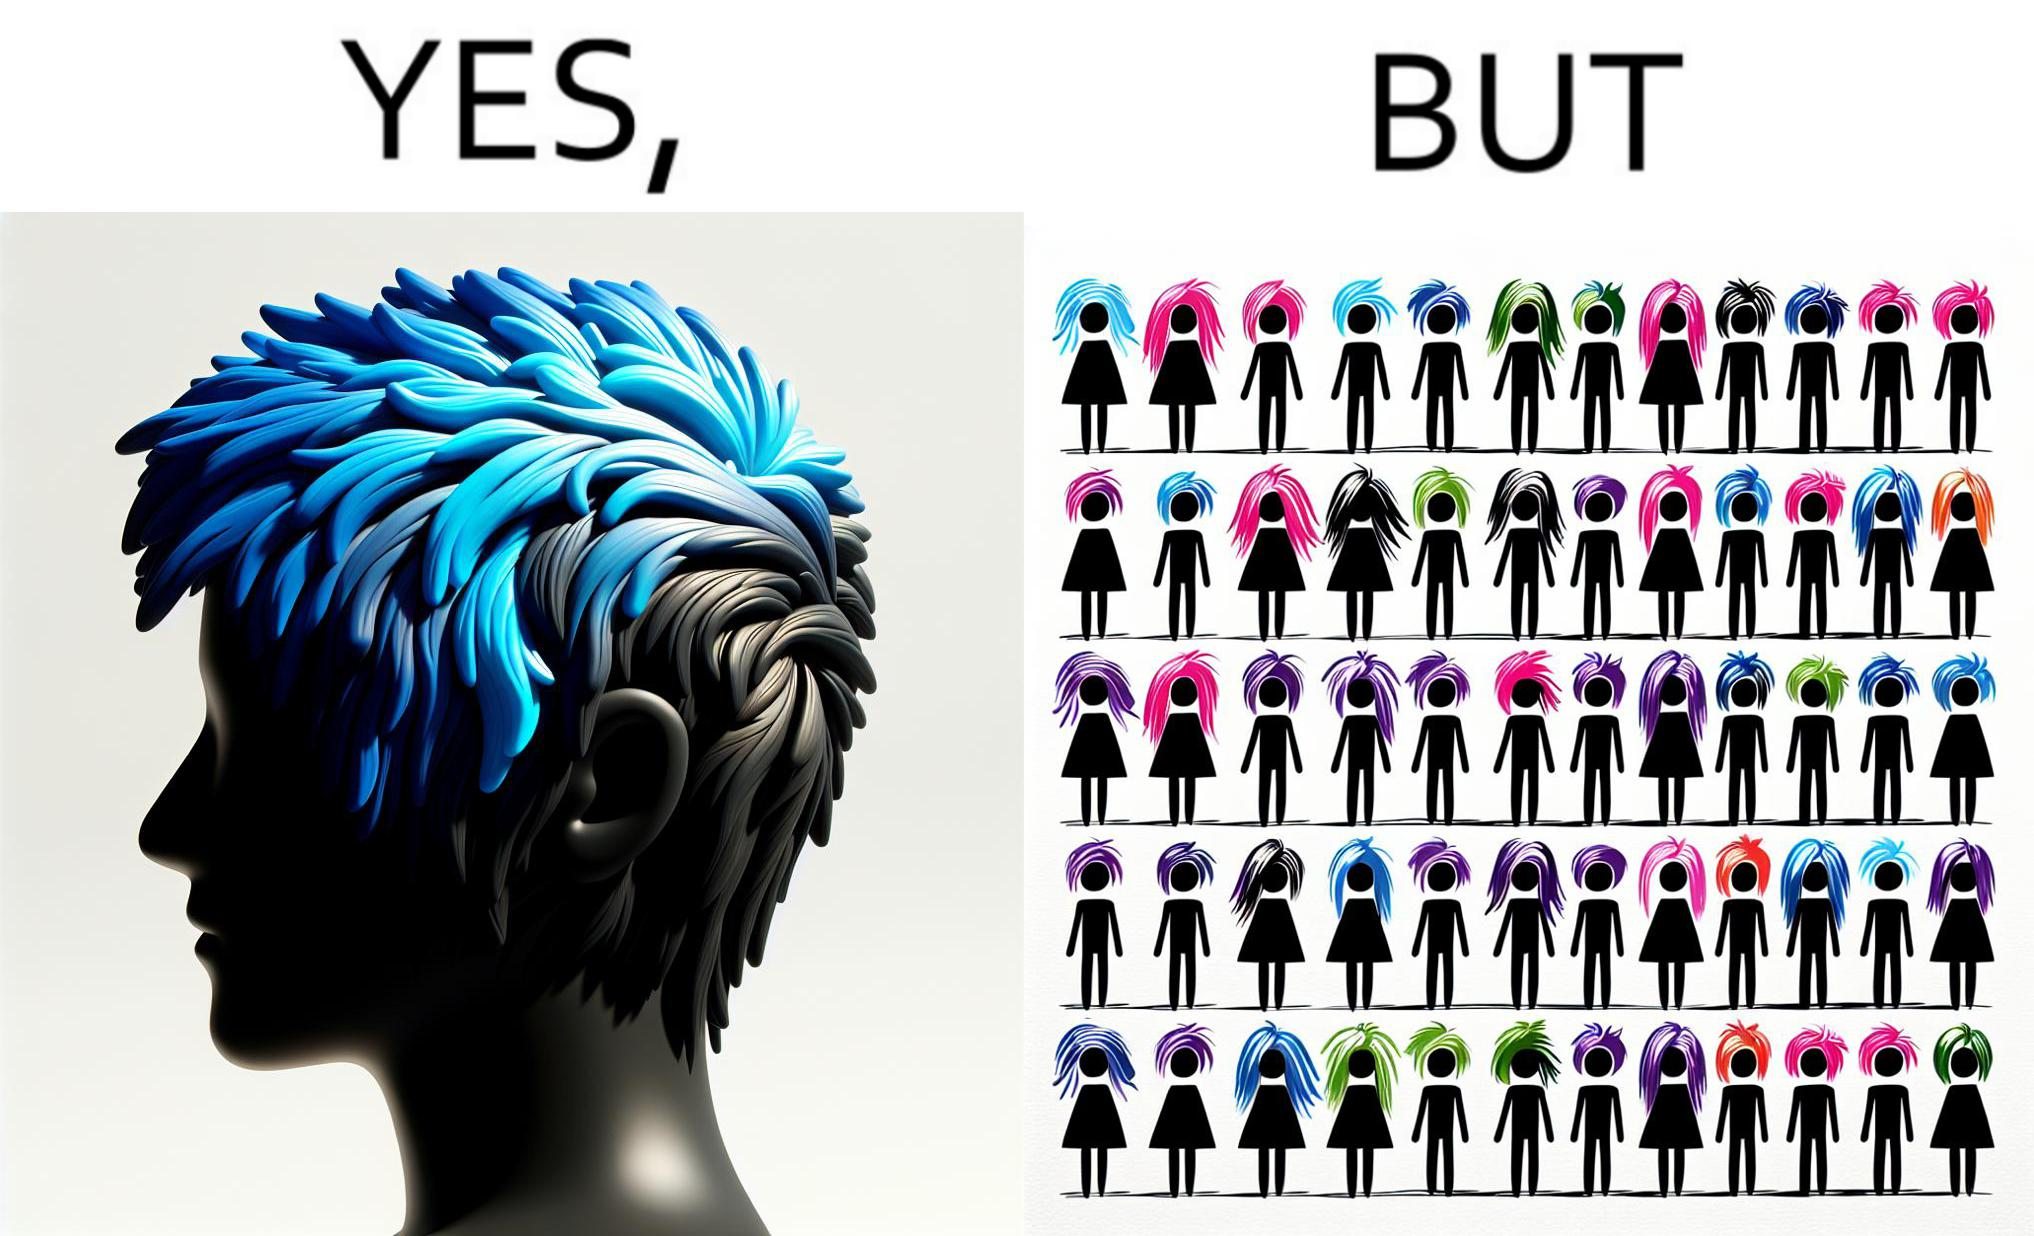What makes this image funny or satirical? The image is funny, as one person with a hair dyed blue seems to symbolize that the person is going against the grain, however, when we zoom out, the group of people have hair dyed in several, different colors, showing that, dyeing hair is the new normal. 